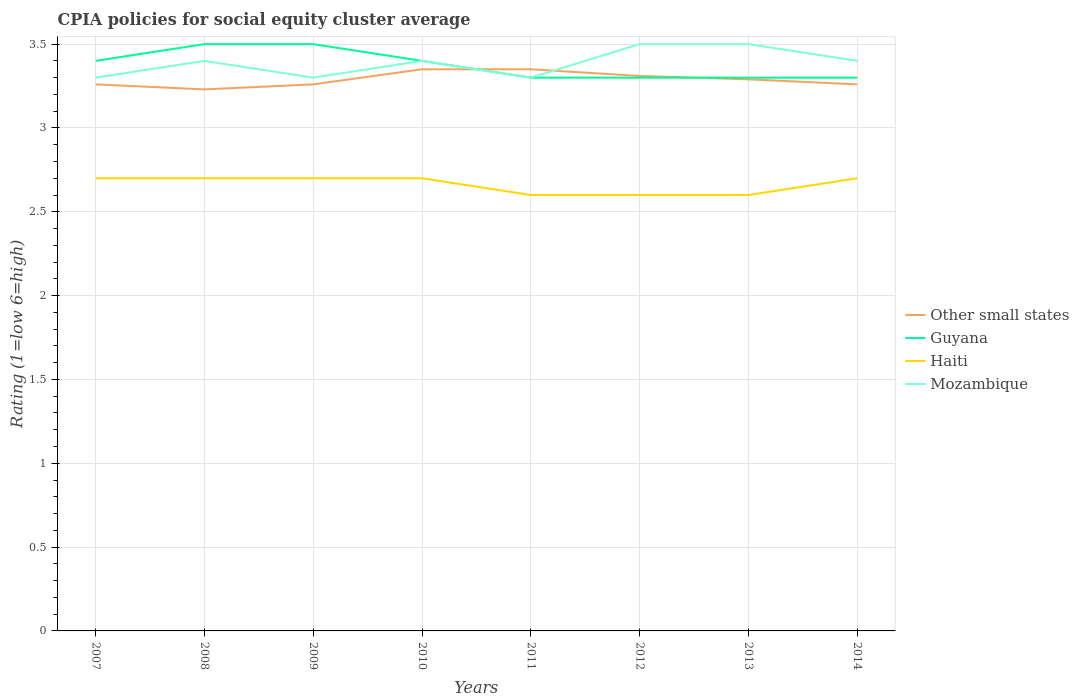How many different coloured lines are there?
Offer a terse response. 4. Is the number of lines equal to the number of legend labels?
Ensure brevity in your answer.  Yes. In which year was the CPIA rating in Other small states maximum?
Offer a very short reply. 2008. What is the total CPIA rating in Other small states in the graph?
Make the answer very short. -0.12. What is the difference between the highest and the second highest CPIA rating in Guyana?
Offer a terse response. 0.2. Does the graph contain any zero values?
Your response must be concise. No. Where does the legend appear in the graph?
Your answer should be very brief. Center right. How many legend labels are there?
Your response must be concise. 4. How are the legend labels stacked?
Provide a short and direct response. Vertical. What is the title of the graph?
Your response must be concise. CPIA policies for social equity cluster average. What is the label or title of the Y-axis?
Your response must be concise. Rating (1=low 6=high). What is the Rating (1=low 6=high) of Other small states in 2007?
Provide a short and direct response. 3.26. What is the Rating (1=low 6=high) of Guyana in 2007?
Ensure brevity in your answer.  3.4. What is the Rating (1=low 6=high) of Other small states in 2008?
Keep it short and to the point. 3.23. What is the Rating (1=low 6=high) of Guyana in 2008?
Provide a succinct answer. 3.5. What is the Rating (1=low 6=high) of Haiti in 2008?
Offer a very short reply. 2.7. What is the Rating (1=low 6=high) of Other small states in 2009?
Keep it short and to the point. 3.26. What is the Rating (1=low 6=high) of Other small states in 2010?
Offer a terse response. 3.35. What is the Rating (1=low 6=high) in Haiti in 2010?
Your answer should be very brief. 2.7. What is the Rating (1=low 6=high) of Other small states in 2011?
Your answer should be compact. 3.35. What is the Rating (1=low 6=high) in Guyana in 2011?
Make the answer very short. 3.3. What is the Rating (1=low 6=high) in Haiti in 2011?
Provide a short and direct response. 2.6. What is the Rating (1=low 6=high) in Other small states in 2012?
Your answer should be very brief. 3.31. What is the Rating (1=low 6=high) of Other small states in 2013?
Ensure brevity in your answer.  3.29. What is the Rating (1=low 6=high) in Haiti in 2013?
Keep it short and to the point. 2.6. What is the Rating (1=low 6=high) in Other small states in 2014?
Make the answer very short. 3.26. What is the Rating (1=low 6=high) of Haiti in 2014?
Make the answer very short. 2.7. What is the Rating (1=low 6=high) in Mozambique in 2014?
Offer a very short reply. 3.4. Across all years, what is the maximum Rating (1=low 6=high) in Other small states?
Ensure brevity in your answer.  3.35. Across all years, what is the minimum Rating (1=low 6=high) of Other small states?
Your answer should be compact. 3.23. Across all years, what is the minimum Rating (1=low 6=high) of Guyana?
Provide a short and direct response. 3.3. Across all years, what is the minimum Rating (1=low 6=high) of Haiti?
Make the answer very short. 2.6. Across all years, what is the minimum Rating (1=low 6=high) of Mozambique?
Your response must be concise. 3.3. What is the total Rating (1=low 6=high) in Other small states in the graph?
Your response must be concise. 26.31. What is the total Rating (1=low 6=high) of Haiti in the graph?
Make the answer very short. 21.3. What is the total Rating (1=low 6=high) in Mozambique in the graph?
Provide a succinct answer. 27.1. What is the difference between the Rating (1=low 6=high) in Guyana in 2007 and that in 2008?
Ensure brevity in your answer.  -0.1. What is the difference between the Rating (1=low 6=high) of Mozambique in 2007 and that in 2008?
Keep it short and to the point. -0.1. What is the difference between the Rating (1=low 6=high) of Other small states in 2007 and that in 2009?
Ensure brevity in your answer.  0. What is the difference between the Rating (1=low 6=high) of Guyana in 2007 and that in 2009?
Give a very brief answer. -0.1. What is the difference between the Rating (1=low 6=high) of Haiti in 2007 and that in 2009?
Your answer should be compact. 0. What is the difference between the Rating (1=low 6=high) of Other small states in 2007 and that in 2010?
Provide a succinct answer. -0.09. What is the difference between the Rating (1=low 6=high) in Mozambique in 2007 and that in 2010?
Ensure brevity in your answer.  -0.1. What is the difference between the Rating (1=low 6=high) in Other small states in 2007 and that in 2011?
Offer a very short reply. -0.09. What is the difference between the Rating (1=low 6=high) in Haiti in 2007 and that in 2011?
Your answer should be compact. 0.1. What is the difference between the Rating (1=low 6=high) in Other small states in 2007 and that in 2012?
Give a very brief answer. -0.05. What is the difference between the Rating (1=low 6=high) in Haiti in 2007 and that in 2012?
Your response must be concise. 0.1. What is the difference between the Rating (1=low 6=high) of Other small states in 2007 and that in 2013?
Keep it short and to the point. -0.03. What is the difference between the Rating (1=low 6=high) of Mozambique in 2007 and that in 2013?
Offer a terse response. -0.2. What is the difference between the Rating (1=low 6=high) in Other small states in 2007 and that in 2014?
Make the answer very short. 0. What is the difference between the Rating (1=low 6=high) of Guyana in 2007 and that in 2014?
Your answer should be compact. 0.1. What is the difference between the Rating (1=low 6=high) of Mozambique in 2007 and that in 2014?
Give a very brief answer. -0.1. What is the difference between the Rating (1=low 6=high) of Other small states in 2008 and that in 2009?
Give a very brief answer. -0.03. What is the difference between the Rating (1=low 6=high) in Guyana in 2008 and that in 2009?
Your answer should be very brief. 0. What is the difference between the Rating (1=low 6=high) of Haiti in 2008 and that in 2009?
Give a very brief answer. 0. What is the difference between the Rating (1=low 6=high) in Mozambique in 2008 and that in 2009?
Provide a succinct answer. 0.1. What is the difference between the Rating (1=low 6=high) in Other small states in 2008 and that in 2010?
Keep it short and to the point. -0.12. What is the difference between the Rating (1=low 6=high) in Guyana in 2008 and that in 2010?
Keep it short and to the point. 0.1. What is the difference between the Rating (1=low 6=high) in Other small states in 2008 and that in 2011?
Your answer should be very brief. -0.12. What is the difference between the Rating (1=low 6=high) of Guyana in 2008 and that in 2011?
Ensure brevity in your answer.  0.2. What is the difference between the Rating (1=low 6=high) of Haiti in 2008 and that in 2011?
Ensure brevity in your answer.  0.1. What is the difference between the Rating (1=low 6=high) in Mozambique in 2008 and that in 2011?
Your answer should be compact. 0.1. What is the difference between the Rating (1=low 6=high) in Other small states in 2008 and that in 2012?
Provide a short and direct response. -0.08. What is the difference between the Rating (1=low 6=high) of Other small states in 2008 and that in 2013?
Give a very brief answer. -0.06. What is the difference between the Rating (1=low 6=high) of Mozambique in 2008 and that in 2013?
Provide a succinct answer. -0.1. What is the difference between the Rating (1=low 6=high) in Other small states in 2008 and that in 2014?
Make the answer very short. -0.03. What is the difference between the Rating (1=low 6=high) of Haiti in 2008 and that in 2014?
Keep it short and to the point. 0. What is the difference between the Rating (1=low 6=high) in Other small states in 2009 and that in 2010?
Provide a succinct answer. -0.09. What is the difference between the Rating (1=low 6=high) in Guyana in 2009 and that in 2010?
Ensure brevity in your answer.  0.1. What is the difference between the Rating (1=low 6=high) in Haiti in 2009 and that in 2010?
Keep it short and to the point. 0. What is the difference between the Rating (1=low 6=high) of Mozambique in 2009 and that in 2010?
Provide a short and direct response. -0.1. What is the difference between the Rating (1=low 6=high) of Other small states in 2009 and that in 2011?
Ensure brevity in your answer.  -0.09. What is the difference between the Rating (1=low 6=high) of Guyana in 2009 and that in 2011?
Offer a terse response. 0.2. What is the difference between the Rating (1=low 6=high) of Guyana in 2009 and that in 2012?
Give a very brief answer. 0.2. What is the difference between the Rating (1=low 6=high) of Haiti in 2009 and that in 2012?
Give a very brief answer. 0.1. What is the difference between the Rating (1=low 6=high) of Mozambique in 2009 and that in 2012?
Provide a short and direct response. -0.2. What is the difference between the Rating (1=low 6=high) of Other small states in 2009 and that in 2013?
Offer a very short reply. -0.03. What is the difference between the Rating (1=low 6=high) in Haiti in 2009 and that in 2013?
Offer a terse response. 0.1. What is the difference between the Rating (1=low 6=high) of Haiti in 2009 and that in 2014?
Ensure brevity in your answer.  0. What is the difference between the Rating (1=low 6=high) in Mozambique in 2009 and that in 2014?
Provide a short and direct response. -0.1. What is the difference between the Rating (1=low 6=high) of Other small states in 2010 and that in 2011?
Keep it short and to the point. 0. What is the difference between the Rating (1=low 6=high) of Guyana in 2010 and that in 2011?
Offer a very short reply. 0.1. What is the difference between the Rating (1=low 6=high) of Haiti in 2010 and that in 2011?
Offer a terse response. 0.1. What is the difference between the Rating (1=low 6=high) in Other small states in 2010 and that in 2012?
Provide a succinct answer. 0.04. What is the difference between the Rating (1=low 6=high) in Guyana in 2010 and that in 2013?
Make the answer very short. 0.1. What is the difference between the Rating (1=low 6=high) of Mozambique in 2010 and that in 2013?
Offer a terse response. -0.1. What is the difference between the Rating (1=low 6=high) in Other small states in 2010 and that in 2014?
Provide a short and direct response. 0.09. What is the difference between the Rating (1=low 6=high) of Haiti in 2010 and that in 2014?
Ensure brevity in your answer.  0. What is the difference between the Rating (1=low 6=high) of Mozambique in 2010 and that in 2014?
Provide a succinct answer. 0. What is the difference between the Rating (1=low 6=high) in Other small states in 2011 and that in 2012?
Offer a very short reply. 0.04. What is the difference between the Rating (1=low 6=high) in Guyana in 2011 and that in 2012?
Offer a very short reply. 0. What is the difference between the Rating (1=low 6=high) of Haiti in 2011 and that in 2012?
Your response must be concise. 0. What is the difference between the Rating (1=low 6=high) in Mozambique in 2011 and that in 2012?
Provide a short and direct response. -0.2. What is the difference between the Rating (1=low 6=high) of Guyana in 2011 and that in 2013?
Provide a succinct answer. 0. What is the difference between the Rating (1=low 6=high) of Haiti in 2011 and that in 2013?
Offer a terse response. 0. What is the difference between the Rating (1=low 6=high) in Other small states in 2011 and that in 2014?
Ensure brevity in your answer.  0.09. What is the difference between the Rating (1=low 6=high) in Guyana in 2011 and that in 2014?
Ensure brevity in your answer.  0. What is the difference between the Rating (1=low 6=high) of Haiti in 2011 and that in 2014?
Provide a succinct answer. -0.1. What is the difference between the Rating (1=low 6=high) of Guyana in 2012 and that in 2013?
Offer a terse response. 0. What is the difference between the Rating (1=low 6=high) in Mozambique in 2012 and that in 2013?
Give a very brief answer. 0. What is the difference between the Rating (1=low 6=high) of Mozambique in 2012 and that in 2014?
Your answer should be very brief. 0.1. What is the difference between the Rating (1=low 6=high) of Haiti in 2013 and that in 2014?
Ensure brevity in your answer.  -0.1. What is the difference between the Rating (1=low 6=high) in Mozambique in 2013 and that in 2014?
Your response must be concise. 0.1. What is the difference between the Rating (1=low 6=high) of Other small states in 2007 and the Rating (1=low 6=high) of Guyana in 2008?
Your answer should be compact. -0.24. What is the difference between the Rating (1=low 6=high) of Other small states in 2007 and the Rating (1=low 6=high) of Haiti in 2008?
Give a very brief answer. 0.56. What is the difference between the Rating (1=low 6=high) of Other small states in 2007 and the Rating (1=low 6=high) of Mozambique in 2008?
Provide a succinct answer. -0.14. What is the difference between the Rating (1=low 6=high) of Haiti in 2007 and the Rating (1=low 6=high) of Mozambique in 2008?
Offer a terse response. -0.7. What is the difference between the Rating (1=low 6=high) of Other small states in 2007 and the Rating (1=low 6=high) of Guyana in 2009?
Your response must be concise. -0.24. What is the difference between the Rating (1=low 6=high) of Other small states in 2007 and the Rating (1=low 6=high) of Haiti in 2009?
Make the answer very short. 0.56. What is the difference between the Rating (1=low 6=high) in Other small states in 2007 and the Rating (1=low 6=high) in Mozambique in 2009?
Provide a short and direct response. -0.04. What is the difference between the Rating (1=low 6=high) in Haiti in 2007 and the Rating (1=low 6=high) in Mozambique in 2009?
Ensure brevity in your answer.  -0.6. What is the difference between the Rating (1=low 6=high) in Other small states in 2007 and the Rating (1=low 6=high) in Guyana in 2010?
Provide a succinct answer. -0.14. What is the difference between the Rating (1=low 6=high) of Other small states in 2007 and the Rating (1=low 6=high) of Haiti in 2010?
Give a very brief answer. 0.56. What is the difference between the Rating (1=low 6=high) of Other small states in 2007 and the Rating (1=low 6=high) of Mozambique in 2010?
Keep it short and to the point. -0.14. What is the difference between the Rating (1=low 6=high) in Guyana in 2007 and the Rating (1=low 6=high) in Haiti in 2010?
Make the answer very short. 0.7. What is the difference between the Rating (1=low 6=high) of Haiti in 2007 and the Rating (1=low 6=high) of Mozambique in 2010?
Offer a terse response. -0.7. What is the difference between the Rating (1=low 6=high) of Other small states in 2007 and the Rating (1=low 6=high) of Guyana in 2011?
Your answer should be compact. -0.04. What is the difference between the Rating (1=low 6=high) in Other small states in 2007 and the Rating (1=low 6=high) in Haiti in 2011?
Your response must be concise. 0.66. What is the difference between the Rating (1=low 6=high) of Other small states in 2007 and the Rating (1=low 6=high) of Mozambique in 2011?
Your answer should be very brief. -0.04. What is the difference between the Rating (1=low 6=high) of Guyana in 2007 and the Rating (1=low 6=high) of Mozambique in 2011?
Make the answer very short. 0.1. What is the difference between the Rating (1=low 6=high) in Haiti in 2007 and the Rating (1=low 6=high) in Mozambique in 2011?
Give a very brief answer. -0.6. What is the difference between the Rating (1=low 6=high) of Other small states in 2007 and the Rating (1=low 6=high) of Guyana in 2012?
Provide a succinct answer. -0.04. What is the difference between the Rating (1=low 6=high) of Other small states in 2007 and the Rating (1=low 6=high) of Haiti in 2012?
Your answer should be very brief. 0.66. What is the difference between the Rating (1=low 6=high) of Other small states in 2007 and the Rating (1=low 6=high) of Mozambique in 2012?
Give a very brief answer. -0.24. What is the difference between the Rating (1=low 6=high) of Guyana in 2007 and the Rating (1=low 6=high) of Haiti in 2012?
Keep it short and to the point. 0.8. What is the difference between the Rating (1=low 6=high) of Other small states in 2007 and the Rating (1=low 6=high) of Guyana in 2013?
Your answer should be very brief. -0.04. What is the difference between the Rating (1=low 6=high) in Other small states in 2007 and the Rating (1=low 6=high) in Haiti in 2013?
Make the answer very short. 0.66. What is the difference between the Rating (1=low 6=high) of Other small states in 2007 and the Rating (1=low 6=high) of Mozambique in 2013?
Make the answer very short. -0.24. What is the difference between the Rating (1=low 6=high) of Guyana in 2007 and the Rating (1=low 6=high) of Mozambique in 2013?
Make the answer very short. -0.1. What is the difference between the Rating (1=low 6=high) in Haiti in 2007 and the Rating (1=low 6=high) in Mozambique in 2013?
Offer a very short reply. -0.8. What is the difference between the Rating (1=low 6=high) in Other small states in 2007 and the Rating (1=low 6=high) in Guyana in 2014?
Provide a succinct answer. -0.04. What is the difference between the Rating (1=low 6=high) in Other small states in 2007 and the Rating (1=low 6=high) in Haiti in 2014?
Give a very brief answer. 0.56. What is the difference between the Rating (1=low 6=high) in Other small states in 2007 and the Rating (1=low 6=high) in Mozambique in 2014?
Make the answer very short. -0.14. What is the difference between the Rating (1=low 6=high) in Guyana in 2007 and the Rating (1=low 6=high) in Haiti in 2014?
Provide a short and direct response. 0.7. What is the difference between the Rating (1=low 6=high) in Guyana in 2007 and the Rating (1=low 6=high) in Mozambique in 2014?
Provide a short and direct response. 0. What is the difference between the Rating (1=low 6=high) of Other small states in 2008 and the Rating (1=low 6=high) of Guyana in 2009?
Your response must be concise. -0.27. What is the difference between the Rating (1=low 6=high) of Other small states in 2008 and the Rating (1=low 6=high) of Haiti in 2009?
Give a very brief answer. 0.53. What is the difference between the Rating (1=low 6=high) in Other small states in 2008 and the Rating (1=low 6=high) in Mozambique in 2009?
Your answer should be compact. -0.07. What is the difference between the Rating (1=low 6=high) in Guyana in 2008 and the Rating (1=low 6=high) in Haiti in 2009?
Offer a very short reply. 0.8. What is the difference between the Rating (1=low 6=high) in Haiti in 2008 and the Rating (1=low 6=high) in Mozambique in 2009?
Your response must be concise. -0.6. What is the difference between the Rating (1=low 6=high) in Other small states in 2008 and the Rating (1=low 6=high) in Guyana in 2010?
Your response must be concise. -0.17. What is the difference between the Rating (1=low 6=high) of Other small states in 2008 and the Rating (1=low 6=high) of Haiti in 2010?
Your answer should be very brief. 0.53. What is the difference between the Rating (1=low 6=high) of Other small states in 2008 and the Rating (1=low 6=high) of Mozambique in 2010?
Provide a short and direct response. -0.17. What is the difference between the Rating (1=low 6=high) of Guyana in 2008 and the Rating (1=low 6=high) of Haiti in 2010?
Give a very brief answer. 0.8. What is the difference between the Rating (1=low 6=high) of Guyana in 2008 and the Rating (1=low 6=high) of Mozambique in 2010?
Ensure brevity in your answer.  0.1. What is the difference between the Rating (1=low 6=high) in Haiti in 2008 and the Rating (1=low 6=high) in Mozambique in 2010?
Provide a succinct answer. -0.7. What is the difference between the Rating (1=low 6=high) in Other small states in 2008 and the Rating (1=low 6=high) in Guyana in 2011?
Give a very brief answer. -0.07. What is the difference between the Rating (1=low 6=high) in Other small states in 2008 and the Rating (1=low 6=high) in Haiti in 2011?
Your answer should be compact. 0.63. What is the difference between the Rating (1=low 6=high) in Other small states in 2008 and the Rating (1=low 6=high) in Mozambique in 2011?
Provide a succinct answer. -0.07. What is the difference between the Rating (1=low 6=high) of Haiti in 2008 and the Rating (1=low 6=high) of Mozambique in 2011?
Your answer should be compact. -0.6. What is the difference between the Rating (1=low 6=high) of Other small states in 2008 and the Rating (1=low 6=high) of Guyana in 2012?
Provide a short and direct response. -0.07. What is the difference between the Rating (1=low 6=high) in Other small states in 2008 and the Rating (1=low 6=high) in Haiti in 2012?
Keep it short and to the point. 0.63. What is the difference between the Rating (1=low 6=high) in Other small states in 2008 and the Rating (1=low 6=high) in Mozambique in 2012?
Provide a succinct answer. -0.27. What is the difference between the Rating (1=low 6=high) of Guyana in 2008 and the Rating (1=low 6=high) of Haiti in 2012?
Provide a succinct answer. 0.9. What is the difference between the Rating (1=low 6=high) in Guyana in 2008 and the Rating (1=low 6=high) in Mozambique in 2012?
Make the answer very short. 0. What is the difference between the Rating (1=low 6=high) of Other small states in 2008 and the Rating (1=low 6=high) of Guyana in 2013?
Provide a succinct answer. -0.07. What is the difference between the Rating (1=low 6=high) in Other small states in 2008 and the Rating (1=low 6=high) in Haiti in 2013?
Ensure brevity in your answer.  0.63. What is the difference between the Rating (1=low 6=high) in Other small states in 2008 and the Rating (1=low 6=high) in Mozambique in 2013?
Your answer should be very brief. -0.27. What is the difference between the Rating (1=low 6=high) of Guyana in 2008 and the Rating (1=low 6=high) of Haiti in 2013?
Give a very brief answer. 0.9. What is the difference between the Rating (1=low 6=high) in Guyana in 2008 and the Rating (1=low 6=high) in Mozambique in 2013?
Your answer should be very brief. 0. What is the difference between the Rating (1=low 6=high) in Haiti in 2008 and the Rating (1=low 6=high) in Mozambique in 2013?
Offer a terse response. -0.8. What is the difference between the Rating (1=low 6=high) in Other small states in 2008 and the Rating (1=low 6=high) in Guyana in 2014?
Provide a succinct answer. -0.07. What is the difference between the Rating (1=low 6=high) of Other small states in 2008 and the Rating (1=low 6=high) of Haiti in 2014?
Your answer should be compact. 0.53. What is the difference between the Rating (1=low 6=high) of Other small states in 2008 and the Rating (1=low 6=high) of Mozambique in 2014?
Make the answer very short. -0.17. What is the difference between the Rating (1=low 6=high) in Guyana in 2008 and the Rating (1=low 6=high) in Haiti in 2014?
Offer a very short reply. 0.8. What is the difference between the Rating (1=low 6=high) in Guyana in 2008 and the Rating (1=low 6=high) in Mozambique in 2014?
Provide a succinct answer. 0.1. What is the difference between the Rating (1=low 6=high) of Haiti in 2008 and the Rating (1=low 6=high) of Mozambique in 2014?
Provide a short and direct response. -0.7. What is the difference between the Rating (1=low 6=high) of Other small states in 2009 and the Rating (1=low 6=high) of Guyana in 2010?
Offer a terse response. -0.14. What is the difference between the Rating (1=low 6=high) in Other small states in 2009 and the Rating (1=low 6=high) in Haiti in 2010?
Make the answer very short. 0.56. What is the difference between the Rating (1=low 6=high) of Other small states in 2009 and the Rating (1=low 6=high) of Mozambique in 2010?
Provide a succinct answer. -0.14. What is the difference between the Rating (1=low 6=high) of Guyana in 2009 and the Rating (1=low 6=high) of Mozambique in 2010?
Give a very brief answer. 0.1. What is the difference between the Rating (1=low 6=high) of Other small states in 2009 and the Rating (1=low 6=high) of Guyana in 2011?
Offer a very short reply. -0.04. What is the difference between the Rating (1=low 6=high) of Other small states in 2009 and the Rating (1=low 6=high) of Haiti in 2011?
Your response must be concise. 0.66. What is the difference between the Rating (1=low 6=high) in Other small states in 2009 and the Rating (1=low 6=high) in Mozambique in 2011?
Provide a succinct answer. -0.04. What is the difference between the Rating (1=low 6=high) in Guyana in 2009 and the Rating (1=low 6=high) in Mozambique in 2011?
Your response must be concise. 0.2. What is the difference between the Rating (1=low 6=high) of Other small states in 2009 and the Rating (1=low 6=high) of Guyana in 2012?
Offer a very short reply. -0.04. What is the difference between the Rating (1=low 6=high) of Other small states in 2009 and the Rating (1=low 6=high) of Haiti in 2012?
Offer a very short reply. 0.66. What is the difference between the Rating (1=low 6=high) in Other small states in 2009 and the Rating (1=low 6=high) in Mozambique in 2012?
Provide a short and direct response. -0.24. What is the difference between the Rating (1=low 6=high) in Guyana in 2009 and the Rating (1=low 6=high) in Haiti in 2012?
Your response must be concise. 0.9. What is the difference between the Rating (1=low 6=high) of Guyana in 2009 and the Rating (1=low 6=high) of Mozambique in 2012?
Keep it short and to the point. 0. What is the difference between the Rating (1=low 6=high) of Other small states in 2009 and the Rating (1=low 6=high) of Guyana in 2013?
Your response must be concise. -0.04. What is the difference between the Rating (1=low 6=high) of Other small states in 2009 and the Rating (1=low 6=high) of Haiti in 2013?
Keep it short and to the point. 0.66. What is the difference between the Rating (1=low 6=high) of Other small states in 2009 and the Rating (1=low 6=high) of Mozambique in 2013?
Your response must be concise. -0.24. What is the difference between the Rating (1=low 6=high) in Haiti in 2009 and the Rating (1=low 6=high) in Mozambique in 2013?
Provide a short and direct response. -0.8. What is the difference between the Rating (1=low 6=high) of Other small states in 2009 and the Rating (1=low 6=high) of Guyana in 2014?
Your answer should be very brief. -0.04. What is the difference between the Rating (1=low 6=high) in Other small states in 2009 and the Rating (1=low 6=high) in Haiti in 2014?
Offer a very short reply. 0.56. What is the difference between the Rating (1=low 6=high) of Other small states in 2009 and the Rating (1=low 6=high) of Mozambique in 2014?
Your answer should be very brief. -0.14. What is the difference between the Rating (1=low 6=high) of Guyana in 2009 and the Rating (1=low 6=high) of Haiti in 2014?
Ensure brevity in your answer.  0.8. What is the difference between the Rating (1=low 6=high) of Guyana in 2009 and the Rating (1=low 6=high) of Mozambique in 2014?
Provide a short and direct response. 0.1. What is the difference between the Rating (1=low 6=high) in Other small states in 2010 and the Rating (1=low 6=high) in Guyana in 2011?
Provide a succinct answer. 0.05. What is the difference between the Rating (1=low 6=high) of Other small states in 2010 and the Rating (1=low 6=high) of Haiti in 2011?
Your answer should be very brief. 0.75. What is the difference between the Rating (1=low 6=high) in Other small states in 2010 and the Rating (1=low 6=high) in Mozambique in 2011?
Your answer should be compact. 0.05. What is the difference between the Rating (1=low 6=high) of Guyana in 2010 and the Rating (1=low 6=high) of Mozambique in 2011?
Give a very brief answer. 0.1. What is the difference between the Rating (1=low 6=high) in Other small states in 2010 and the Rating (1=low 6=high) in Guyana in 2013?
Provide a succinct answer. 0.05. What is the difference between the Rating (1=low 6=high) in Other small states in 2010 and the Rating (1=low 6=high) in Haiti in 2013?
Your answer should be compact. 0.75. What is the difference between the Rating (1=low 6=high) of Other small states in 2010 and the Rating (1=low 6=high) of Mozambique in 2013?
Give a very brief answer. -0.15. What is the difference between the Rating (1=low 6=high) in Haiti in 2010 and the Rating (1=low 6=high) in Mozambique in 2013?
Give a very brief answer. -0.8. What is the difference between the Rating (1=low 6=high) in Other small states in 2010 and the Rating (1=low 6=high) in Guyana in 2014?
Keep it short and to the point. 0.05. What is the difference between the Rating (1=low 6=high) in Other small states in 2010 and the Rating (1=low 6=high) in Haiti in 2014?
Provide a short and direct response. 0.65. What is the difference between the Rating (1=low 6=high) of Other small states in 2010 and the Rating (1=low 6=high) of Mozambique in 2014?
Keep it short and to the point. -0.05. What is the difference between the Rating (1=low 6=high) in Guyana in 2010 and the Rating (1=low 6=high) in Haiti in 2014?
Offer a terse response. 0.7. What is the difference between the Rating (1=low 6=high) in Guyana in 2010 and the Rating (1=low 6=high) in Mozambique in 2014?
Provide a succinct answer. 0. What is the difference between the Rating (1=low 6=high) of Other small states in 2011 and the Rating (1=low 6=high) of Mozambique in 2012?
Make the answer very short. -0.15. What is the difference between the Rating (1=low 6=high) in Guyana in 2011 and the Rating (1=low 6=high) in Mozambique in 2012?
Your answer should be compact. -0.2. What is the difference between the Rating (1=low 6=high) in Haiti in 2011 and the Rating (1=low 6=high) in Mozambique in 2012?
Your answer should be compact. -0.9. What is the difference between the Rating (1=low 6=high) in Other small states in 2011 and the Rating (1=low 6=high) in Guyana in 2013?
Ensure brevity in your answer.  0.05. What is the difference between the Rating (1=low 6=high) of Other small states in 2011 and the Rating (1=low 6=high) of Haiti in 2013?
Your answer should be very brief. 0.75. What is the difference between the Rating (1=low 6=high) in Other small states in 2011 and the Rating (1=low 6=high) in Mozambique in 2013?
Keep it short and to the point. -0.15. What is the difference between the Rating (1=low 6=high) in Guyana in 2011 and the Rating (1=low 6=high) in Haiti in 2013?
Your answer should be very brief. 0.7. What is the difference between the Rating (1=low 6=high) in Guyana in 2011 and the Rating (1=low 6=high) in Mozambique in 2013?
Make the answer very short. -0.2. What is the difference between the Rating (1=low 6=high) in Other small states in 2011 and the Rating (1=low 6=high) in Haiti in 2014?
Give a very brief answer. 0.65. What is the difference between the Rating (1=low 6=high) in Other small states in 2011 and the Rating (1=low 6=high) in Mozambique in 2014?
Provide a succinct answer. -0.05. What is the difference between the Rating (1=low 6=high) in Guyana in 2011 and the Rating (1=low 6=high) in Mozambique in 2014?
Offer a very short reply. -0.1. What is the difference between the Rating (1=low 6=high) of Haiti in 2011 and the Rating (1=low 6=high) of Mozambique in 2014?
Your response must be concise. -0.8. What is the difference between the Rating (1=low 6=high) of Other small states in 2012 and the Rating (1=low 6=high) of Guyana in 2013?
Keep it short and to the point. 0.01. What is the difference between the Rating (1=low 6=high) in Other small states in 2012 and the Rating (1=low 6=high) in Haiti in 2013?
Ensure brevity in your answer.  0.71. What is the difference between the Rating (1=low 6=high) of Other small states in 2012 and the Rating (1=low 6=high) of Mozambique in 2013?
Offer a very short reply. -0.19. What is the difference between the Rating (1=low 6=high) in Guyana in 2012 and the Rating (1=low 6=high) in Mozambique in 2013?
Your answer should be compact. -0.2. What is the difference between the Rating (1=low 6=high) in Haiti in 2012 and the Rating (1=low 6=high) in Mozambique in 2013?
Your answer should be very brief. -0.9. What is the difference between the Rating (1=low 6=high) in Other small states in 2012 and the Rating (1=low 6=high) in Guyana in 2014?
Keep it short and to the point. 0.01. What is the difference between the Rating (1=low 6=high) in Other small states in 2012 and the Rating (1=low 6=high) in Haiti in 2014?
Offer a very short reply. 0.61. What is the difference between the Rating (1=low 6=high) of Other small states in 2012 and the Rating (1=low 6=high) of Mozambique in 2014?
Your response must be concise. -0.09. What is the difference between the Rating (1=low 6=high) of Guyana in 2012 and the Rating (1=low 6=high) of Mozambique in 2014?
Give a very brief answer. -0.1. What is the difference between the Rating (1=low 6=high) in Haiti in 2012 and the Rating (1=low 6=high) in Mozambique in 2014?
Keep it short and to the point. -0.8. What is the difference between the Rating (1=low 6=high) of Other small states in 2013 and the Rating (1=low 6=high) of Guyana in 2014?
Your answer should be very brief. -0.01. What is the difference between the Rating (1=low 6=high) of Other small states in 2013 and the Rating (1=low 6=high) of Haiti in 2014?
Give a very brief answer. 0.59. What is the difference between the Rating (1=low 6=high) in Other small states in 2013 and the Rating (1=low 6=high) in Mozambique in 2014?
Offer a terse response. -0.11. What is the difference between the Rating (1=low 6=high) of Guyana in 2013 and the Rating (1=low 6=high) of Mozambique in 2014?
Keep it short and to the point. -0.1. What is the difference between the Rating (1=low 6=high) in Haiti in 2013 and the Rating (1=low 6=high) in Mozambique in 2014?
Ensure brevity in your answer.  -0.8. What is the average Rating (1=low 6=high) of Other small states per year?
Your answer should be compact. 3.29. What is the average Rating (1=low 6=high) in Guyana per year?
Make the answer very short. 3.38. What is the average Rating (1=low 6=high) in Haiti per year?
Provide a short and direct response. 2.66. What is the average Rating (1=low 6=high) of Mozambique per year?
Provide a short and direct response. 3.39. In the year 2007, what is the difference between the Rating (1=low 6=high) of Other small states and Rating (1=low 6=high) of Guyana?
Provide a short and direct response. -0.14. In the year 2007, what is the difference between the Rating (1=low 6=high) of Other small states and Rating (1=low 6=high) of Haiti?
Your response must be concise. 0.56. In the year 2007, what is the difference between the Rating (1=low 6=high) in Other small states and Rating (1=low 6=high) in Mozambique?
Your response must be concise. -0.04. In the year 2007, what is the difference between the Rating (1=low 6=high) in Guyana and Rating (1=low 6=high) in Haiti?
Make the answer very short. 0.7. In the year 2008, what is the difference between the Rating (1=low 6=high) in Other small states and Rating (1=low 6=high) in Guyana?
Offer a very short reply. -0.27. In the year 2008, what is the difference between the Rating (1=low 6=high) in Other small states and Rating (1=low 6=high) in Haiti?
Ensure brevity in your answer.  0.53. In the year 2008, what is the difference between the Rating (1=low 6=high) in Other small states and Rating (1=low 6=high) in Mozambique?
Your answer should be very brief. -0.17. In the year 2008, what is the difference between the Rating (1=low 6=high) in Guyana and Rating (1=low 6=high) in Haiti?
Keep it short and to the point. 0.8. In the year 2009, what is the difference between the Rating (1=low 6=high) in Other small states and Rating (1=low 6=high) in Guyana?
Provide a succinct answer. -0.24. In the year 2009, what is the difference between the Rating (1=low 6=high) of Other small states and Rating (1=low 6=high) of Haiti?
Make the answer very short. 0.56. In the year 2009, what is the difference between the Rating (1=low 6=high) of Other small states and Rating (1=low 6=high) of Mozambique?
Provide a short and direct response. -0.04. In the year 2009, what is the difference between the Rating (1=low 6=high) in Haiti and Rating (1=low 6=high) in Mozambique?
Your response must be concise. -0.6. In the year 2010, what is the difference between the Rating (1=low 6=high) in Other small states and Rating (1=low 6=high) in Haiti?
Offer a terse response. 0.65. In the year 2010, what is the difference between the Rating (1=low 6=high) of Guyana and Rating (1=low 6=high) of Haiti?
Offer a terse response. 0.7. In the year 2011, what is the difference between the Rating (1=low 6=high) of Guyana and Rating (1=low 6=high) of Mozambique?
Offer a terse response. 0. In the year 2012, what is the difference between the Rating (1=low 6=high) in Other small states and Rating (1=low 6=high) in Guyana?
Provide a short and direct response. 0.01. In the year 2012, what is the difference between the Rating (1=low 6=high) in Other small states and Rating (1=low 6=high) in Haiti?
Your answer should be very brief. 0.71. In the year 2012, what is the difference between the Rating (1=low 6=high) in Other small states and Rating (1=low 6=high) in Mozambique?
Your answer should be very brief. -0.19. In the year 2012, what is the difference between the Rating (1=low 6=high) of Guyana and Rating (1=low 6=high) of Mozambique?
Keep it short and to the point. -0.2. In the year 2013, what is the difference between the Rating (1=low 6=high) in Other small states and Rating (1=low 6=high) in Guyana?
Give a very brief answer. -0.01. In the year 2013, what is the difference between the Rating (1=low 6=high) of Other small states and Rating (1=low 6=high) of Haiti?
Offer a very short reply. 0.69. In the year 2013, what is the difference between the Rating (1=low 6=high) in Other small states and Rating (1=low 6=high) in Mozambique?
Your answer should be very brief. -0.21. In the year 2013, what is the difference between the Rating (1=low 6=high) in Guyana and Rating (1=low 6=high) in Mozambique?
Make the answer very short. -0.2. In the year 2014, what is the difference between the Rating (1=low 6=high) of Other small states and Rating (1=low 6=high) of Guyana?
Ensure brevity in your answer.  -0.04. In the year 2014, what is the difference between the Rating (1=low 6=high) in Other small states and Rating (1=low 6=high) in Haiti?
Ensure brevity in your answer.  0.56. In the year 2014, what is the difference between the Rating (1=low 6=high) in Other small states and Rating (1=low 6=high) in Mozambique?
Your answer should be compact. -0.14. What is the ratio of the Rating (1=low 6=high) in Other small states in 2007 to that in 2008?
Offer a terse response. 1.01. What is the ratio of the Rating (1=low 6=high) in Guyana in 2007 to that in 2008?
Your answer should be very brief. 0.97. What is the ratio of the Rating (1=low 6=high) of Haiti in 2007 to that in 2008?
Make the answer very short. 1. What is the ratio of the Rating (1=low 6=high) of Mozambique in 2007 to that in 2008?
Ensure brevity in your answer.  0.97. What is the ratio of the Rating (1=low 6=high) in Other small states in 2007 to that in 2009?
Your response must be concise. 1. What is the ratio of the Rating (1=low 6=high) of Guyana in 2007 to that in 2009?
Ensure brevity in your answer.  0.97. What is the ratio of the Rating (1=low 6=high) of Haiti in 2007 to that in 2009?
Keep it short and to the point. 1. What is the ratio of the Rating (1=low 6=high) in Other small states in 2007 to that in 2010?
Your answer should be very brief. 0.97. What is the ratio of the Rating (1=low 6=high) of Mozambique in 2007 to that in 2010?
Your answer should be compact. 0.97. What is the ratio of the Rating (1=low 6=high) in Other small states in 2007 to that in 2011?
Ensure brevity in your answer.  0.97. What is the ratio of the Rating (1=low 6=high) of Guyana in 2007 to that in 2011?
Keep it short and to the point. 1.03. What is the ratio of the Rating (1=low 6=high) in Haiti in 2007 to that in 2011?
Ensure brevity in your answer.  1.04. What is the ratio of the Rating (1=low 6=high) of Mozambique in 2007 to that in 2011?
Ensure brevity in your answer.  1. What is the ratio of the Rating (1=low 6=high) in Other small states in 2007 to that in 2012?
Keep it short and to the point. 0.98. What is the ratio of the Rating (1=low 6=high) of Guyana in 2007 to that in 2012?
Ensure brevity in your answer.  1.03. What is the ratio of the Rating (1=low 6=high) in Mozambique in 2007 to that in 2012?
Ensure brevity in your answer.  0.94. What is the ratio of the Rating (1=low 6=high) in Other small states in 2007 to that in 2013?
Offer a terse response. 0.99. What is the ratio of the Rating (1=low 6=high) of Guyana in 2007 to that in 2013?
Your answer should be compact. 1.03. What is the ratio of the Rating (1=low 6=high) in Mozambique in 2007 to that in 2013?
Provide a succinct answer. 0.94. What is the ratio of the Rating (1=low 6=high) in Guyana in 2007 to that in 2014?
Keep it short and to the point. 1.03. What is the ratio of the Rating (1=low 6=high) in Mozambique in 2007 to that in 2014?
Keep it short and to the point. 0.97. What is the ratio of the Rating (1=low 6=high) of Mozambique in 2008 to that in 2009?
Provide a short and direct response. 1.03. What is the ratio of the Rating (1=low 6=high) in Other small states in 2008 to that in 2010?
Offer a very short reply. 0.96. What is the ratio of the Rating (1=low 6=high) in Guyana in 2008 to that in 2010?
Offer a very short reply. 1.03. What is the ratio of the Rating (1=low 6=high) of Haiti in 2008 to that in 2010?
Offer a terse response. 1. What is the ratio of the Rating (1=low 6=high) in Mozambique in 2008 to that in 2010?
Offer a very short reply. 1. What is the ratio of the Rating (1=low 6=high) of Other small states in 2008 to that in 2011?
Keep it short and to the point. 0.96. What is the ratio of the Rating (1=low 6=high) in Guyana in 2008 to that in 2011?
Keep it short and to the point. 1.06. What is the ratio of the Rating (1=low 6=high) of Haiti in 2008 to that in 2011?
Your answer should be very brief. 1.04. What is the ratio of the Rating (1=low 6=high) of Mozambique in 2008 to that in 2011?
Provide a short and direct response. 1.03. What is the ratio of the Rating (1=low 6=high) in Other small states in 2008 to that in 2012?
Give a very brief answer. 0.98. What is the ratio of the Rating (1=low 6=high) of Guyana in 2008 to that in 2012?
Offer a terse response. 1.06. What is the ratio of the Rating (1=low 6=high) of Mozambique in 2008 to that in 2012?
Keep it short and to the point. 0.97. What is the ratio of the Rating (1=low 6=high) in Other small states in 2008 to that in 2013?
Provide a short and direct response. 0.98. What is the ratio of the Rating (1=low 6=high) of Guyana in 2008 to that in 2013?
Provide a short and direct response. 1.06. What is the ratio of the Rating (1=low 6=high) in Mozambique in 2008 to that in 2013?
Ensure brevity in your answer.  0.97. What is the ratio of the Rating (1=low 6=high) of Other small states in 2008 to that in 2014?
Keep it short and to the point. 0.99. What is the ratio of the Rating (1=low 6=high) of Guyana in 2008 to that in 2014?
Your answer should be very brief. 1.06. What is the ratio of the Rating (1=low 6=high) of Haiti in 2008 to that in 2014?
Give a very brief answer. 1. What is the ratio of the Rating (1=low 6=high) of Mozambique in 2008 to that in 2014?
Give a very brief answer. 1. What is the ratio of the Rating (1=low 6=high) of Other small states in 2009 to that in 2010?
Ensure brevity in your answer.  0.97. What is the ratio of the Rating (1=low 6=high) in Guyana in 2009 to that in 2010?
Your response must be concise. 1.03. What is the ratio of the Rating (1=low 6=high) in Haiti in 2009 to that in 2010?
Keep it short and to the point. 1. What is the ratio of the Rating (1=low 6=high) of Mozambique in 2009 to that in 2010?
Offer a very short reply. 0.97. What is the ratio of the Rating (1=low 6=high) in Other small states in 2009 to that in 2011?
Offer a very short reply. 0.97. What is the ratio of the Rating (1=low 6=high) of Guyana in 2009 to that in 2011?
Offer a terse response. 1.06. What is the ratio of the Rating (1=low 6=high) in Haiti in 2009 to that in 2011?
Give a very brief answer. 1.04. What is the ratio of the Rating (1=low 6=high) of Mozambique in 2009 to that in 2011?
Your answer should be very brief. 1. What is the ratio of the Rating (1=low 6=high) in Other small states in 2009 to that in 2012?
Offer a terse response. 0.98. What is the ratio of the Rating (1=low 6=high) of Guyana in 2009 to that in 2012?
Make the answer very short. 1.06. What is the ratio of the Rating (1=low 6=high) of Mozambique in 2009 to that in 2012?
Keep it short and to the point. 0.94. What is the ratio of the Rating (1=low 6=high) in Other small states in 2009 to that in 2013?
Offer a terse response. 0.99. What is the ratio of the Rating (1=low 6=high) of Guyana in 2009 to that in 2013?
Make the answer very short. 1.06. What is the ratio of the Rating (1=low 6=high) in Mozambique in 2009 to that in 2013?
Offer a very short reply. 0.94. What is the ratio of the Rating (1=low 6=high) in Other small states in 2009 to that in 2014?
Offer a very short reply. 1. What is the ratio of the Rating (1=low 6=high) in Guyana in 2009 to that in 2014?
Make the answer very short. 1.06. What is the ratio of the Rating (1=low 6=high) in Mozambique in 2009 to that in 2014?
Make the answer very short. 0.97. What is the ratio of the Rating (1=low 6=high) in Other small states in 2010 to that in 2011?
Keep it short and to the point. 1. What is the ratio of the Rating (1=low 6=high) in Guyana in 2010 to that in 2011?
Give a very brief answer. 1.03. What is the ratio of the Rating (1=low 6=high) in Mozambique in 2010 to that in 2011?
Make the answer very short. 1.03. What is the ratio of the Rating (1=low 6=high) of Other small states in 2010 to that in 2012?
Provide a short and direct response. 1.01. What is the ratio of the Rating (1=low 6=high) in Guyana in 2010 to that in 2012?
Provide a succinct answer. 1.03. What is the ratio of the Rating (1=low 6=high) of Mozambique in 2010 to that in 2012?
Offer a very short reply. 0.97. What is the ratio of the Rating (1=low 6=high) in Other small states in 2010 to that in 2013?
Provide a short and direct response. 1.02. What is the ratio of the Rating (1=low 6=high) in Guyana in 2010 to that in 2013?
Ensure brevity in your answer.  1.03. What is the ratio of the Rating (1=low 6=high) of Mozambique in 2010 to that in 2013?
Your response must be concise. 0.97. What is the ratio of the Rating (1=low 6=high) of Other small states in 2010 to that in 2014?
Keep it short and to the point. 1.03. What is the ratio of the Rating (1=low 6=high) of Guyana in 2010 to that in 2014?
Your answer should be very brief. 1.03. What is the ratio of the Rating (1=low 6=high) in Mozambique in 2010 to that in 2014?
Give a very brief answer. 1. What is the ratio of the Rating (1=low 6=high) of Other small states in 2011 to that in 2012?
Keep it short and to the point. 1.01. What is the ratio of the Rating (1=low 6=high) in Haiti in 2011 to that in 2012?
Offer a terse response. 1. What is the ratio of the Rating (1=low 6=high) of Mozambique in 2011 to that in 2012?
Your answer should be very brief. 0.94. What is the ratio of the Rating (1=low 6=high) of Other small states in 2011 to that in 2013?
Offer a terse response. 1.02. What is the ratio of the Rating (1=low 6=high) of Guyana in 2011 to that in 2013?
Make the answer very short. 1. What is the ratio of the Rating (1=low 6=high) in Haiti in 2011 to that in 2013?
Give a very brief answer. 1. What is the ratio of the Rating (1=low 6=high) in Mozambique in 2011 to that in 2013?
Make the answer very short. 0.94. What is the ratio of the Rating (1=low 6=high) in Other small states in 2011 to that in 2014?
Ensure brevity in your answer.  1.03. What is the ratio of the Rating (1=low 6=high) in Guyana in 2011 to that in 2014?
Your response must be concise. 1. What is the ratio of the Rating (1=low 6=high) of Haiti in 2011 to that in 2014?
Your response must be concise. 0.96. What is the ratio of the Rating (1=low 6=high) in Mozambique in 2011 to that in 2014?
Offer a very short reply. 0.97. What is the ratio of the Rating (1=low 6=high) of Guyana in 2012 to that in 2013?
Your answer should be compact. 1. What is the ratio of the Rating (1=low 6=high) of Haiti in 2012 to that in 2013?
Provide a short and direct response. 1. What is the ratio of the Rating (1=low 6=high) in Other small states in 2012 to that in 2014?
Make the answer very short. 1.02. What is the ratio of the Rating (1=low 6=high) in Guyana in 2012 to that in 2014?
Provide a short and direct response. 1. What is the ratio of the Rating (1=low 6=high) in Mozambique in 2012 to that in 2014?
Provide a succinct answer. 1.03. What is the ratio of the Rating (1=low 6=high) in Other small states in 2013 to that in 2014?
Your answer should be compact. 1.01. What is the ratio of the Rating (1=low 6=high) in Mozambique in 2013 to that in 2014?
Provide a succinct answer. 1.03. What is the difference between the highest and the second highest Rating (1=low 6=high) in Other small states?
Give a very brief answer. 0. What is the difference between the highest and the second highest Rating (1=low 6=high) in Haiti?
Your response must be concise. 0. What is the difference between the highest and the second highest Rating (1=low 6=high) in Mozambique?
Offer a terse response. 0. What is the difference between the highest and the lowest Rating (1=low 6=high) of Other small states?
Your response must be concise. 0.12. What is the difference between the highest and the lowest Rating (1=low 6=high) in Haiti?
Keep it short and to the point. 0.1. What is the difference between the highest and the lowest Rating (1=low 6=high) in Mozambique?
Ensure brevity in your answer.  0.2. 